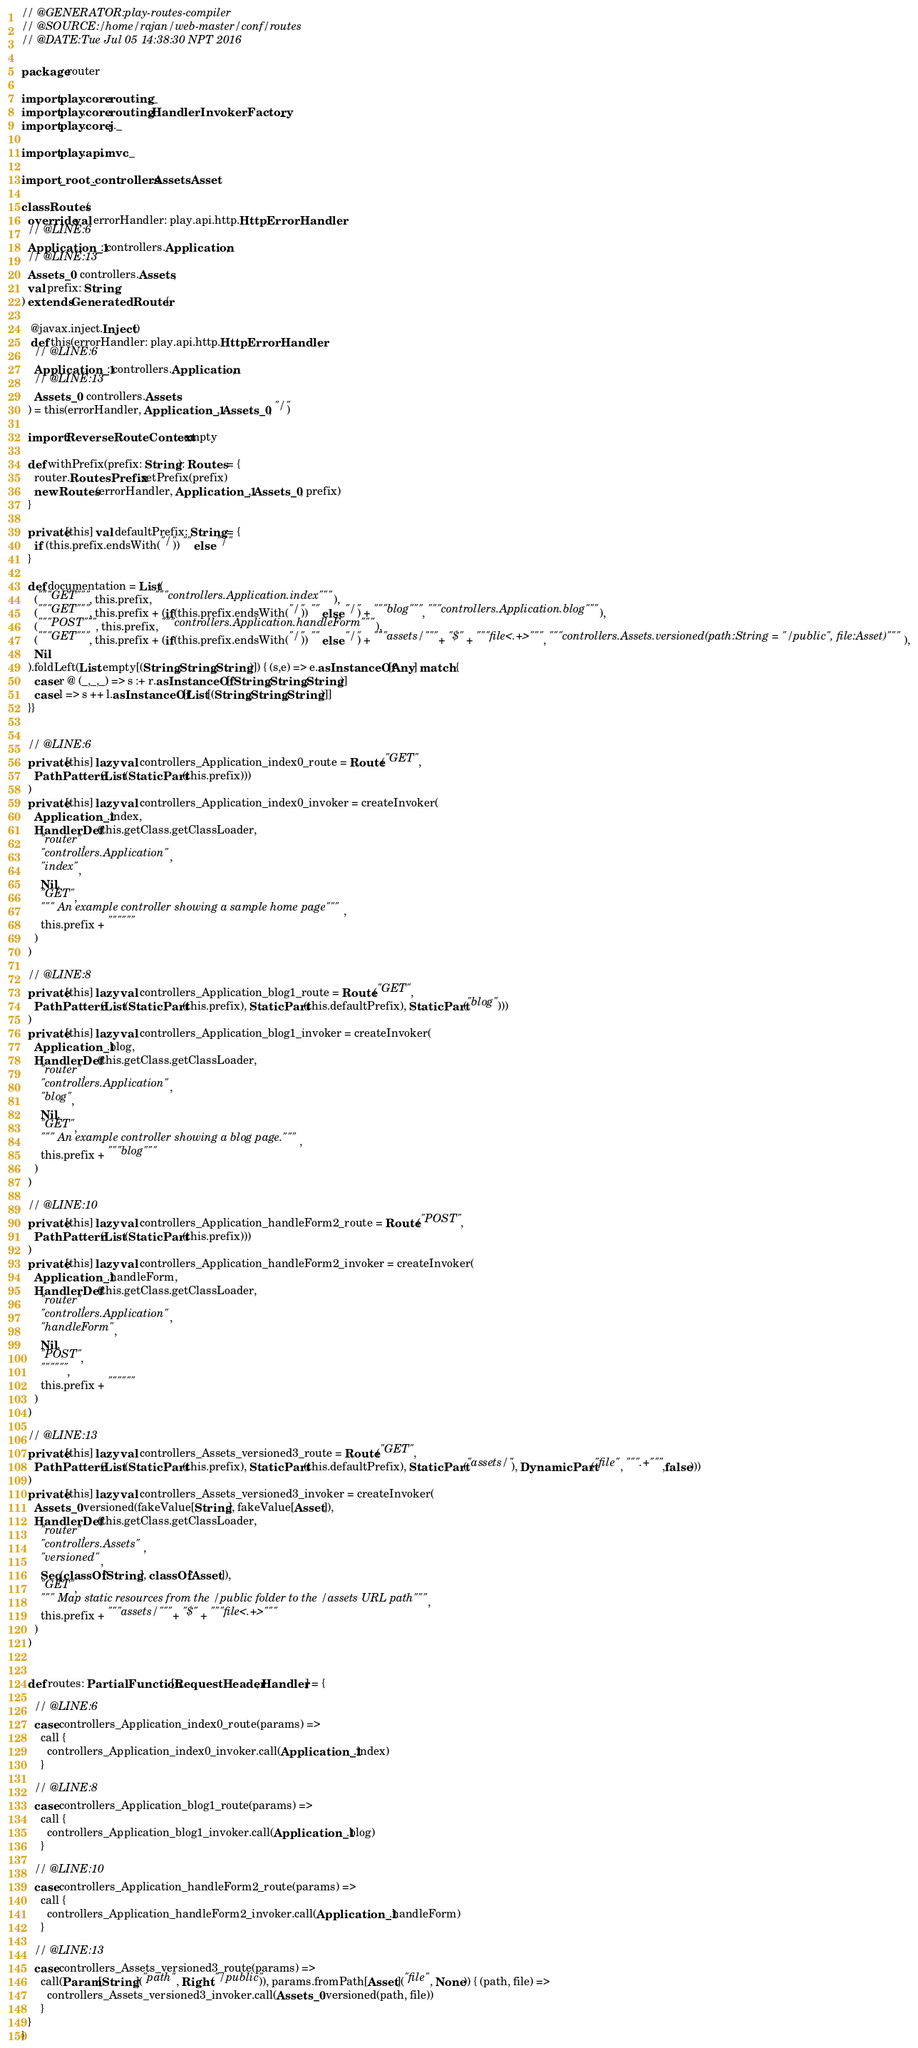<code> <loc_0><loc_0><loc_500><loc_500><_Scala_>
// @GENERATOR:play-routes-compiler
// @SOURCE:/home/rajan/web-master/conf/routes
// @DATE:Tue Jul 05 14:38:30 NPT 2016

package router

import play.core.routing._
import play.core.routing.HandlerInvokerFactory._
import play.core.j._

import play.api.mvc._

import _root_.controllers.Assets.Asset

class Routes(
  override val errorHandler: play.api.http.HttpErrorHandler, 
  // @LINE:6
  Application_1: controllers.Application,
  // @LINE:13
  Assets_0: controllers.Assets,
  val prefix: String
) extends GeneratedRouter {

   @javax.inject.Inject()
   def this(errorHandler: play.api.http.HttpErrorHandler,
    // @LINE:6
    Application_1: controllers.Application,
    // @LINE:13
    Assets_0: controllers.Assets
  ) = this(errorHandler, Application_1, Assets_0, "/")

  import ReverseRouteContext.empty

  def withPrefix(prefix: String): Routes = {
    router.RoutesPrefix.setPrefix(prefix)
    new Routes(errorHandler, Application_1, Assets_0, prefix)
  }

  private[this] val defaultPrefix: String = {
    if (this.prefix.endsWith("/")) "" else "/"
  }

  def documentation = List(
    ("""GET""", this.prefix, """controllers.Application.index"""),
    ("""GET""", this.prefix + (if(this.prefix.endsWith("/")) "" else "/") + """blog""", """controllers.Application.blog"""),
    ("""POST""", this.prefix, """controllers.Application.handleForm"""),
    ("""GET""", this.prefix + (if(this.prefix.endsWith("/")) "" else "/") + """assets/""" + "$" + """file<.+>""", """controllers.Assets.versioned(path:String = "/public", file:Asset)"""),
    Nil
  ).foldLeft(List.empty[(String,String,String)]) { (s,e) => e.asInstanceOf[Any] match {
    case r @ (_,_,_) => s :+ r.asInstanceOf[(String,String,String)]
    case l => s ++ l.asInstanceOf[List[(String,String,String)]]
  }}


  // @LINE:6
  private[this] lazy val controllers_Application_index0_route = Route("GET",
    PathPattern(List(StaticPart(this.prefix)))
  )
  private[this] lazy val controllers_Application_index0_invoker = createInvoker(
    Application_1.index,
    HandlerDef(this.getClass.getClassLoader,
      "router",
      "controllers.Application",
      "index",
      Nil,
      "GET",
      """ An example controller showing a sample home page""",
      this.prefix + """"""
    )
  )

  // @LINE:8
  private[this] lazy val controllers_Application_blog1_route = Route("GET",
    PathPattern(List(StaticPart(this.prefix), StaticPart(this.defaultPrefix), StaticPart("blog")))
  )
  private[this] lazy val controllers_Application_blog1_invoker = createInvoker(
    Application_1.blog,
    HandlerDef(this.getClass.getClassLoader,
      "router",
      "controllers.Application",
      "blog",
      Nil,
      "GET",
      """ An example controller showing a blog page.""",
      this.prefix + """blog"""
    )
  )

  // @LINE:10
  private[this] lazy val controllers_Application_handleForm2_route = Route("POST",
    PathPattern(List(StaticPart(this.prefix)))
  )
  private[this] lazy val controllers_Application_handleForm2_invoker = createInvoker(
    Application_1.handleForm,
    HandlerDef(this.getClass.getClassLoader,
      "router",
      "controllers.Application",
      "handleForm",
      Nil,
      "POST",
      """""",
      this.prefix + """"""
    )
  )

  // @LINE:13
  private[this] lazy val controllers_Assets_versioned3_route = Route("GET",
    PathPattern(List(StaticPart(this.prefix), StaticPart(this.defaultPrefix), StaticPart("assets/"), DynamicPart("file", """.+""",false)))
  )
  private[this] lazy val controllers_Assets_versioned3_invoker = createInvoker(
    Assets_0.versioned(fakeValue[String], fakeValue[Asset]),
    HandlerDef(this.getClass.getClassLoader,
      "router",
      "controllers.Assets",
      "versioned",
      Seq(classOf[String], classOf[Asset]),
      "GET",
      """ Map static resources from the /public folder to the /assets URL path""",
      this.prefix + """assets/""" + "$" + """file<.+>"""
    )
  )


  def routes: PartialFunction[RequestHeader, Handler] = {
  
    // @LINE:6
    case controllers_Application_index0_route(params) =>
      call { 
        controllers_Application_index0_invoker.call(Application_1.index)
      }
  
    // @LINE:8
    case controllers_Application_blog1_route(params) =>
      call { 
        controllers_Application_blog1_invoker.call(Application_1.blog)
      }
  
    // @LINE:10
    case controllers_Application_handleForm2_route(params) =>
      call { 
        controllers_Application_handleForm2_invoker.call(Application_1.handleForm)
      }
  
    // @LINE:13
    case controllers_Assets_versioned3_route(params) =>
      call(Param[String]("path", Right("/public")), params.fromPath[Asset]("file", None)) { (path, file) =>
        controllers_Assets_versioned3_invoker.call(Assets_0.versioned(path, file))
      }
  }
}
</code> 